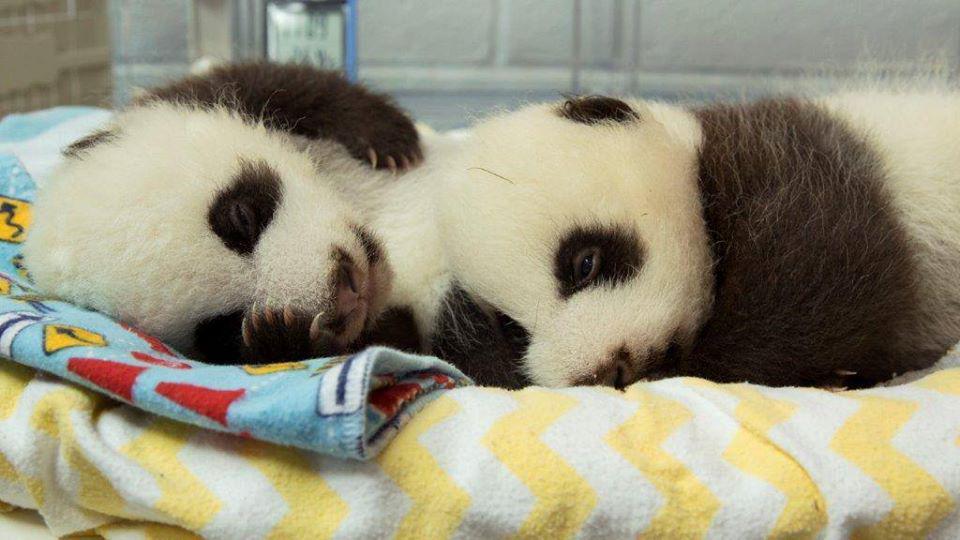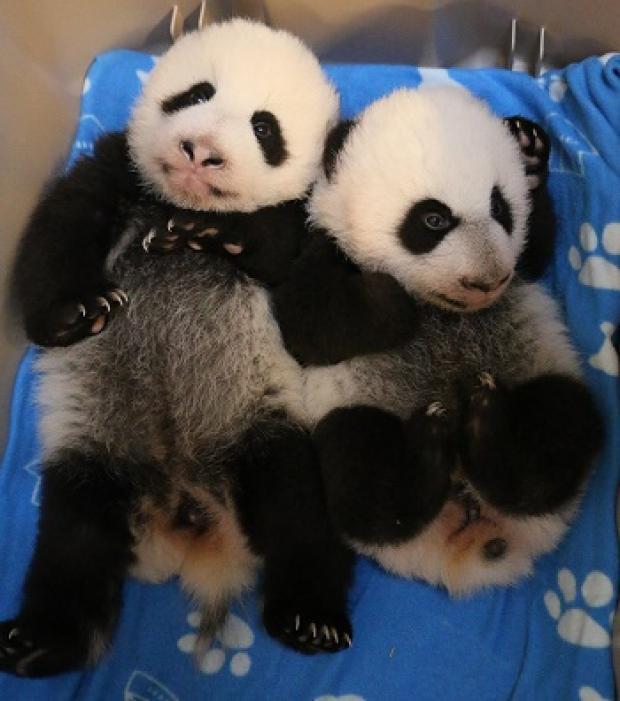The first image is the image on the left, the second image is the image on the right. For the images shown, is this caption "One image contains twice as many pandas as the other image, and one panda has an open mouth and wide-open eyes." true? Answer yes or no. No. The first image is the image on the left, the second image is the image on the right. Evaluate the accuracy of this statement regarding the images: "In one image, a small panda is being held at an indoor location by a person who is wearing a medical protective item.". Is it true? Answer yes or no. No. 